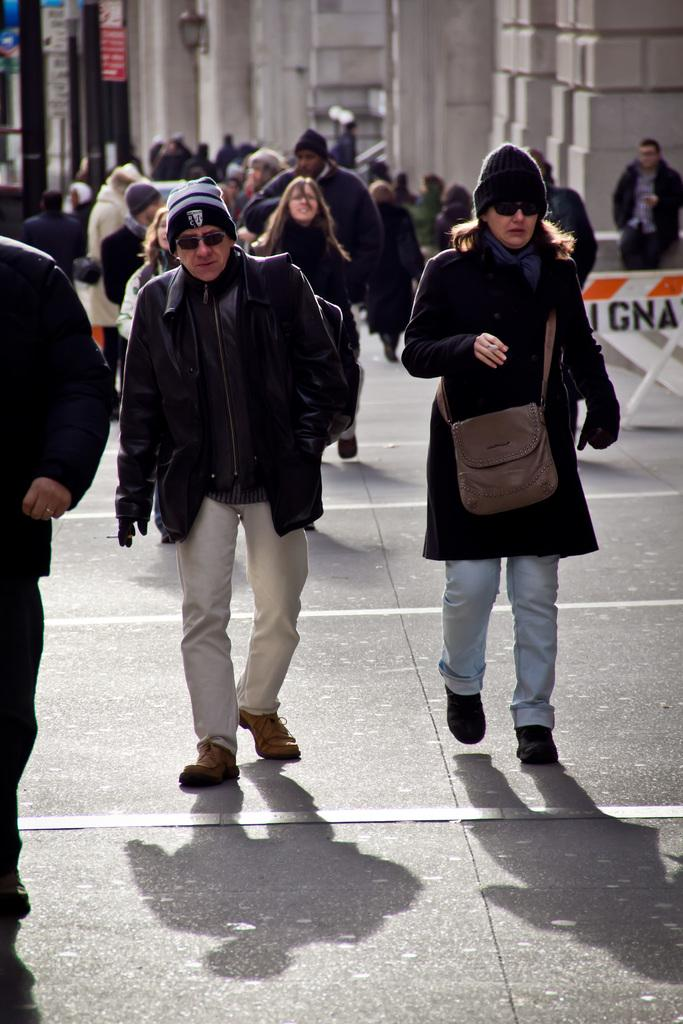What are the people in the image doing? Some people are standing, and some are walking on the road in the image. What can be seen in the background of the image? There are buildings, street poles, street lights, advertisement boards, and plants in the background of the image. What type of arithmetic problem is being solved by the kitten in the image? There is no kitten present in the image, and therefore no arithmetic problem can be observed. What is the color of the potato in the image? There is no potato present in the image. 